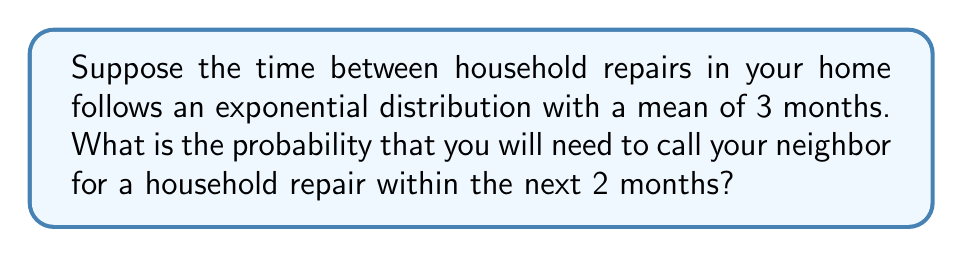Could you help me with this problem? Let's approach this step-by-step:

1) The exponential distribution is often used to model the time between events in a Poisson process. In this case, it's modeling the time between household repairs.

2) The probability density function of an exponential distribution is:

   $$f(t) = \lambda e^{-\lambda t}$$

   where $\lambda$ is the rate parameter.

3) We're given that the mean time between repairs is 3 months. For an exponential distribution, the mean is equal to $1/\lambda$. So:

   $$\frac{1}{\lambda} = 3$$
   $$\lambda = \frac{1}{3}$$

4) We want to find the probability of a repair being needed within 2 months. This is equivalent to finding the probability that the time until the next repair is less than or equal to 2 months.

5) For an exponential distribution, this probability is given by:

   $$P(T \leq t) = 1 - e^{-\lambda t}$$

6) Substituting our values:

   $$P(T \leq 2) = 1 - e^{-\frac{1}{3} \cdot 2}$$

7) Simplifying:

   $$P(T \leq 2) = 1 - e^{-\frac{2}{3}}$$
   $$P(T \leq 2) = 1 - (e^{-1})^{\frac{2}{3}}$$
   $$P(T \leq 2) = 1 - (0.3679)^{\frac{2}{3}}$$
   $$P(T \leq 2) \approx 0.4866$$

8) Therefore, the probability of needing a household repair within the next 2 months is approximately 0.4866 or 48.66%.
Answer: 0.4866 